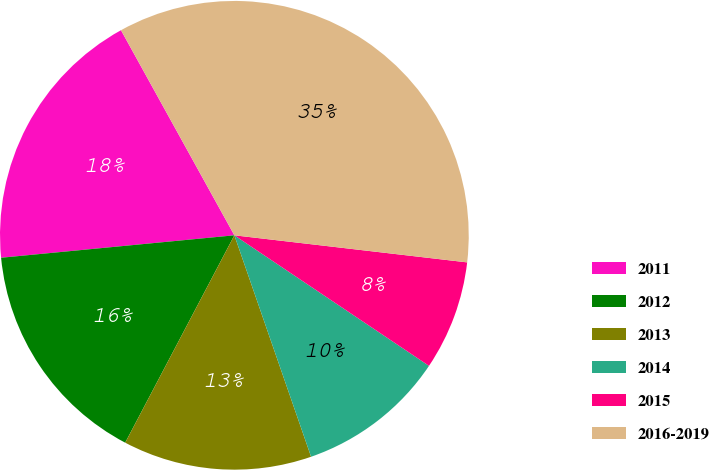Convert chart. <chart><loc_0><loc_0><loc_500><loc_500><pie_chart><fcel>2011<fcel>2012<fcel>2013<fcel>2014<fcel>2015<fcel>2016-2019<nl><fcel>18.49%<fcel>15.76%<fcel>13.02%<fcel>10.29%<fcel>7.56%<fcel>34.88%<nl></chart> 